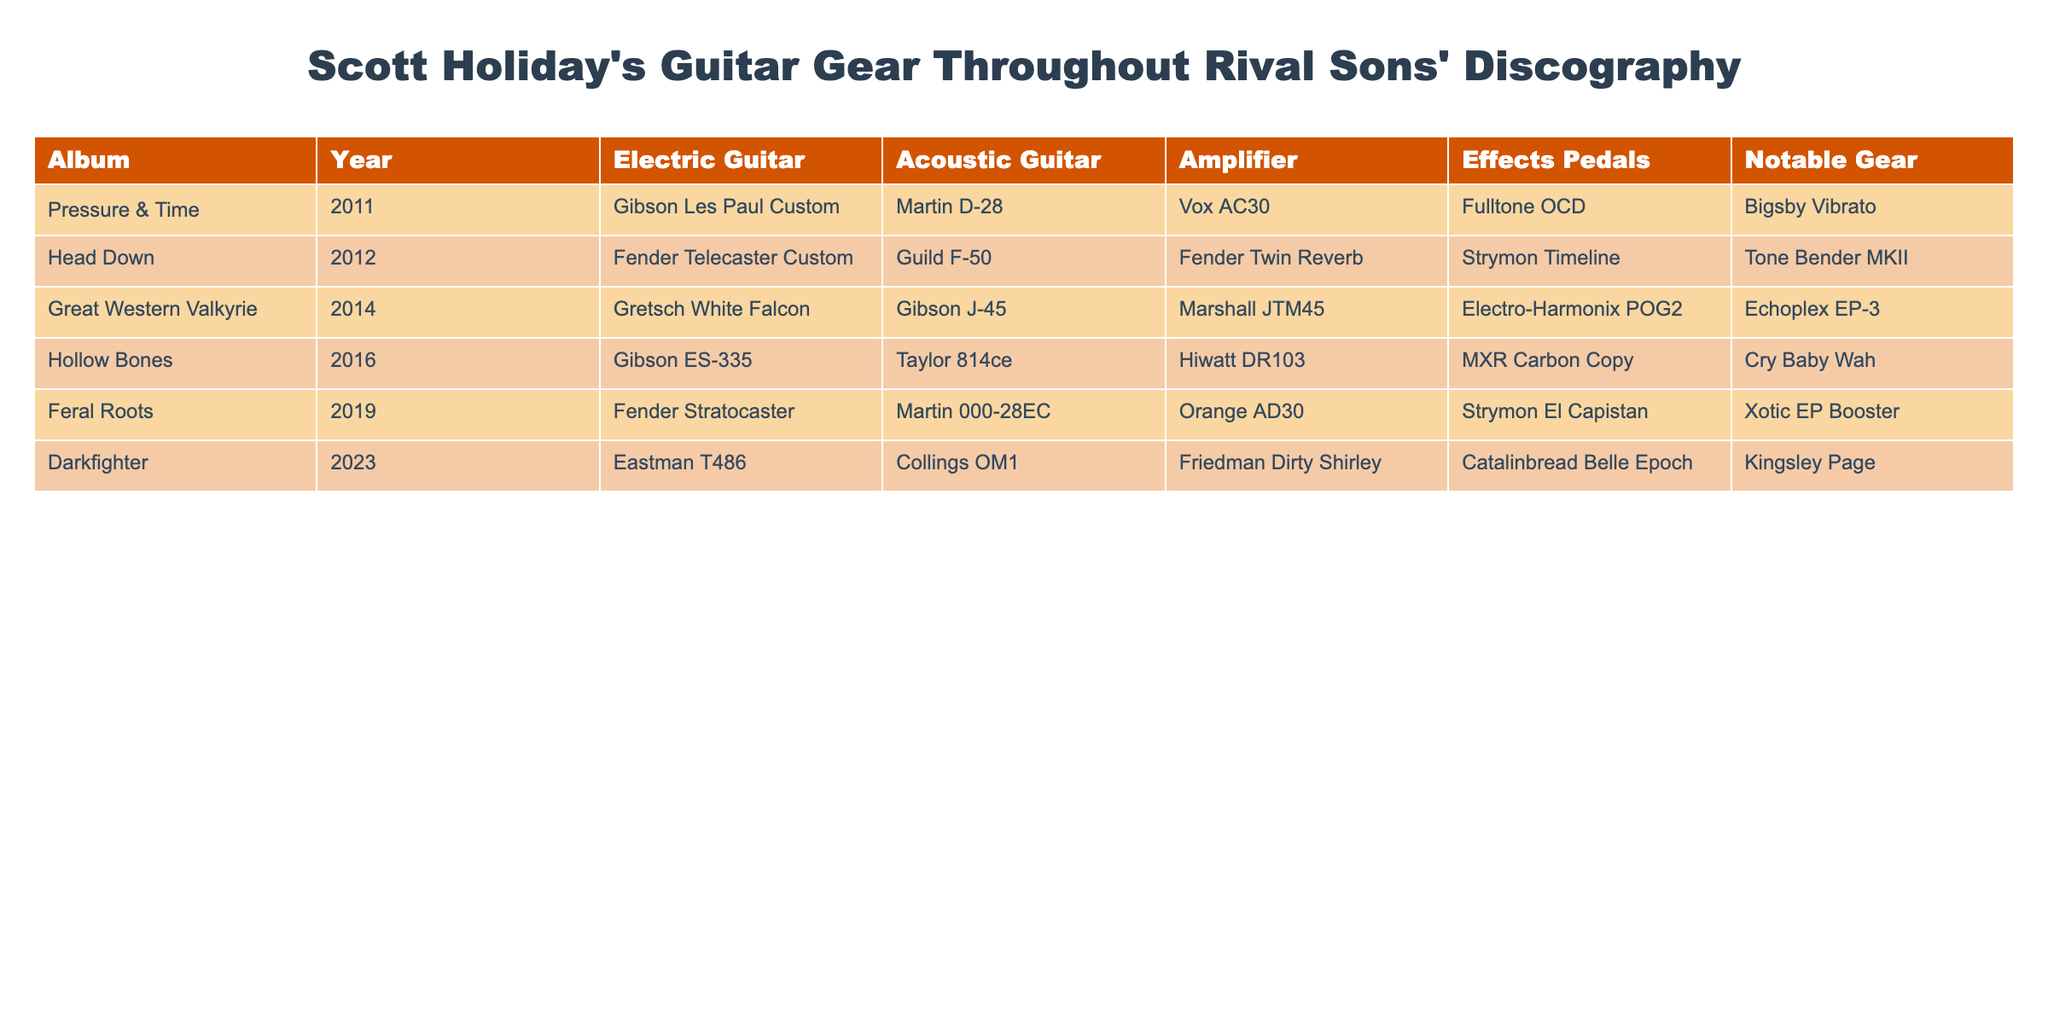What electric guitar did Scott Holiday use in the album "Feral Roots"? Referring to the table, we can see that in the row corresponding to the album "Feral Roots," the electric guitar listed is the Fender Stratocaster.
Answer: Fender Stratocaster Which album features the Gibson Les Paul Custom? Looking at the table, we find that the Gibson Les Paul Custom is associated with the album "Pressure & Time."
Answer: Pressure & Time How many different acoustic guitars are listed across all albums? Counting the acoustic guitar entries in the table: Martin D-28 (1), Guild F-50 (2), Gibson J-45 (3), Taylor 814ce (4), Martin 000-28EC (5), and Collings OM1 (6). There are 6 unique acoustic guitars listed.
Answer: 6 What is the most recent amplifier used by Scott Holiday? Checking the last row in the table, which is "Darkfighter," the amplifier used is the Friedman Dirty Shirley. This is the last album listed, hence it is the most recent.
Answer: Friedman Dirty Shirley Did Scott Holiday use a Fulltone OCD on the "Head Down" album? Looking at the "Head Down" row, we notice that the effects pedal used is the Strymon Timeline, not the Fulltone OCD. Thus, the statement is false.
Answer: No Which amplifier was used in both "Great Western Valkyrie" and "Hollow Bones"? By examining the table, we find the Marshall JTM45 for "Great Western Valkyrie" and Hiwatt DR103 for "Hollow Bones." Thus, no amplifiers are shared between these two albums.
Answer: None How many albums feature the Fender Telecaster Custom as the electric guitar? The table indicates that the Fender Telecaster Custom appears once, in the "Head Down" album. Therefore, the count is 1.
Answer: 1 What are the differences in the electric guitars used from "Pressure & Time" to "Feral Roots"? The electric guitar shifts from Gibson Les Paul Custom in "Pressure & Time" to Fender Stratocaster in "Feral Roots." There are two different electric guitars used across these albums.
Answer: 2 different guitars Which year did Scott Holiday begin using the Hiwatt DR103 amplifier? Referring to the table, the Hiwatt DR103 is used in the "Hollow Bones" album, which was released in 2016. Thus, that is the year he began using it.
Answer: 2016 Was there any album where Scott Holiday used a Gretsch White Falcon? The table shows that the Gretsch White Falcon was used in the album "Great Western Valkyrie." Thus, the answer is yes that it was used.
Answer: Yes 